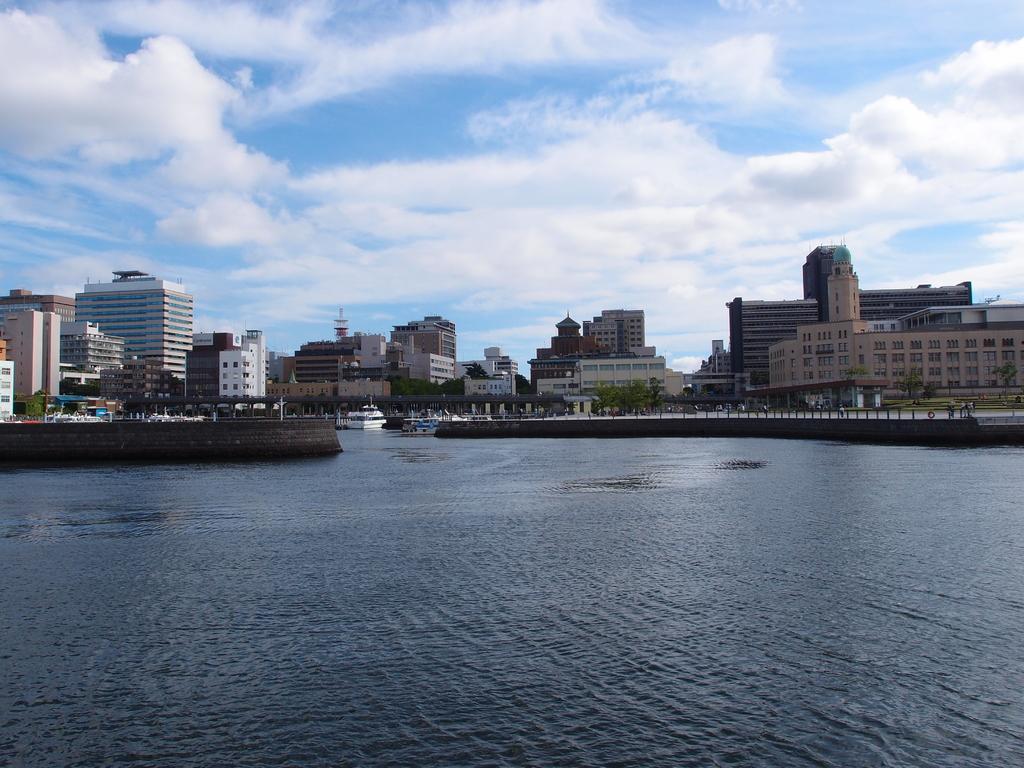In one or two sentences, can you explain what this image depicts? In this image we can see the water and there are some boats and we can see some building in the background. We can see some trees and at the top we can see the sky. 